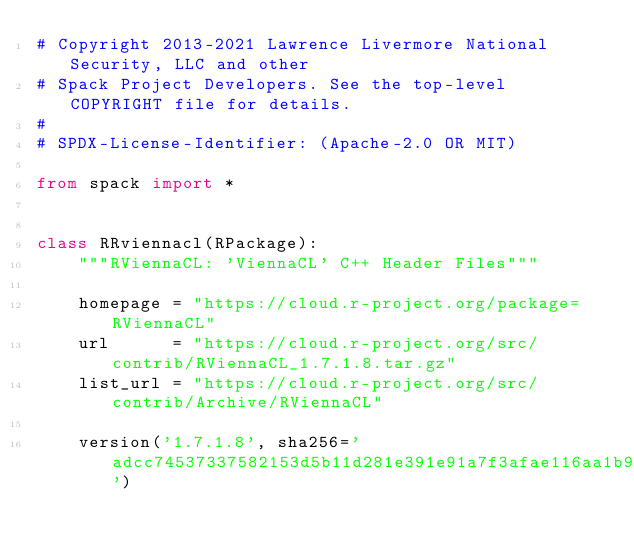<code> <loc_0><loc_0><loc_500><loc_500><_Python_># Copyright 2013-2021 Lawrence Livermore National Security, LLC and other
# Spack Project Developers. See the top-level COPYRIGHT file for details.
#
# SPDX-License-Identifier: (Apache-2.0 OR MIT)

from spack import *


class RRviennacl(RPackage):
    """RViennaCL: 'ViennaCL' C++ Header Files"""

    homepage = "https://cloud.r-project.org/package=RViennaCL"
    url      = "https://cloud.r-project.org/src/contrib/RViennaCL_1.7.1.8.tar.gz"
    list_url = "https://cloud.r-project.org/src/contrib/Archive/RViennaCL"

    version('1.7.1.8', sha256='adcc74537337582153d5b11d281e391e91a7f3afae116aa1b9a034ffd11b0252')
</code> 